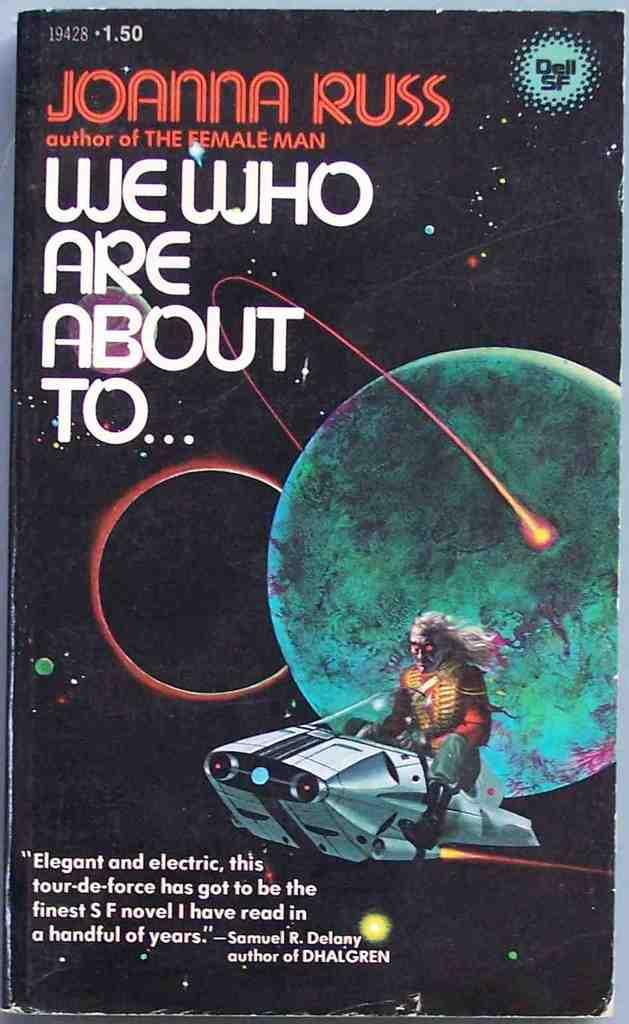<image>
Summarize the visual content of the image. A book cover titled We Who Are About To by Joanna Russ and a picture of an alien on a space ship 